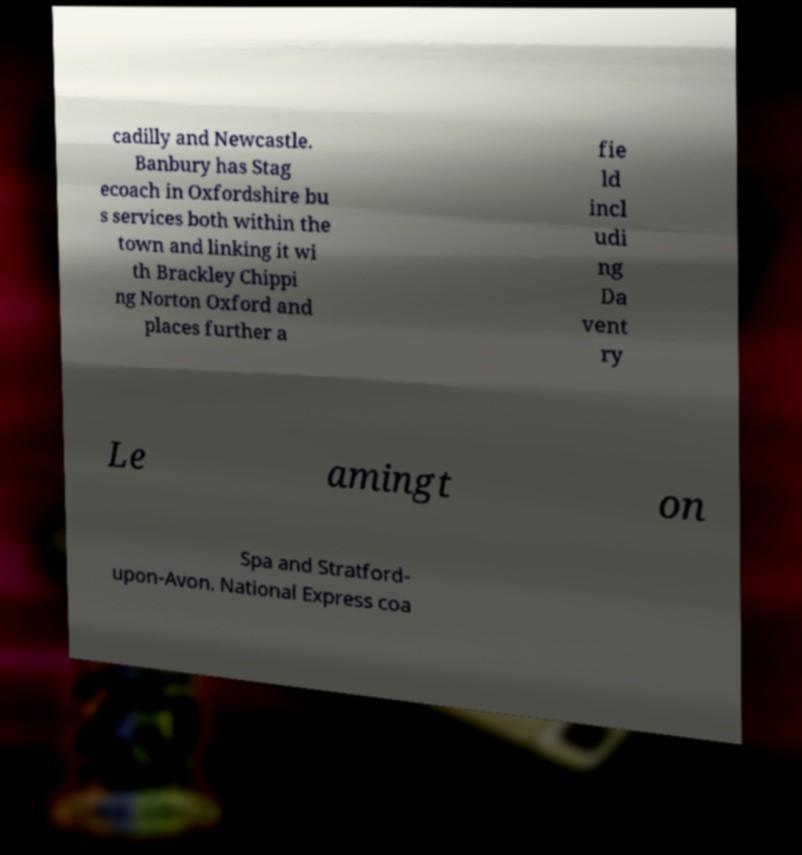I need the written content from this picture converted into text. Can you do that? cadilly and Newcastle. Banbury has Stag ecoach in Oxfordshire bu s services both within the town and linking it wi th Brackley Chippi ng Norton Oxford and places further a fie ld incl udi ng Da vent ry Le amingt on Spa and Stratford- upon-Avon. National Express coa 